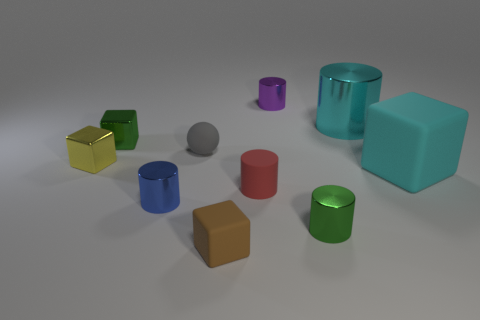There is another large object that is the same color as the large metal thing; what material is it?
Give a very brief answer. Rubber. What size is the cyan shiny cylinder?
Offer a very short reply. Large. There is a sphere; does it have the same color as the large thing in front of the cyan shiny thing?
Your response must be concise. No. What is the color of the rubber block that is in front of the big cyan thing in front of the yellow metallic thing?
Offer a terse response. Brown. There is a yellow thing behind the tiny blue thing; does it have the same shape as the brown matte object?
Your response must be concise. Yes. What number of things are both to the left of the green cylinder and behind the small green cylinder?
Ensure brevity in your answer.  6. There is a block in front of the cyan object that is to the right of the big thing that is behind the cyan matte object; what color is it?
Provide a short and direct response. Brown. How many tiny rubber objects are behind the tiny green object that is in front of the matte ball?
Provide a short and direct response. 2. What number of other objects are there of the same shape as the large rubber object?
Make the answer very short. 3. How many objects are large objects or small blocks behind the big block?
Your answer should be compact. 4. 